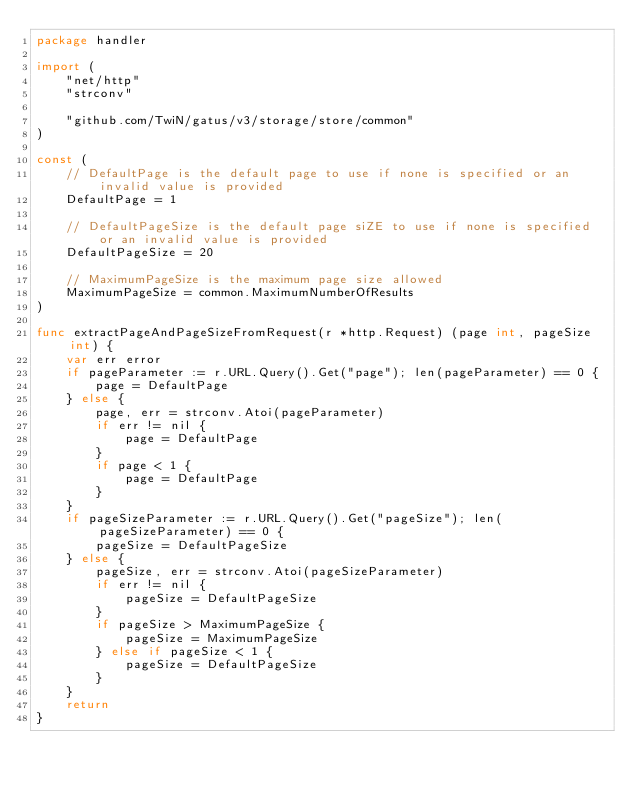<code> <loc_0><loc_0><loc_500><loc_500><_Go_>package handler

import (
	"net/http"
	"strconv"

	"github.com/TwiN/gatus/v3/storage/store/common"
)

const (
	// DefaultPage is the default page to use if none is specified or an invalid value is provided
	DefaultPage = 1

	// DefaultPageSize is the default page siZE to use if none is specified or an invalid value is provided
	DefaultPageSize = 20

	// MaximumPageSize is the maximum page size allowed
	MaximumPageSize = common.MaximumNumberOfResults
)

func extractPageAndPageSizeFromRequest(r *http.Request) (page int, pageSize int) {
	var err error
	if pageParameter := r.URL.Query().Get("page"); len(pageParameter) == 0 {
		page = DefaultPage
	} else {
		page, err = strconv.Atoi(pageParameter)
		if err != nil {
			page = DefaultPage
		}
		if page < 1 {
			page = DefaultPage
		}
	}
	if pageSizeParameter := r.URL.Query().Get("pageSize"); len(pageSizeParameter) == 0 {
		pageSize = DefaultPageSize
	} else {
		pageSize, err = strconv.Atoi(pageSizeParameter)
		if err != nil {
			pageSize = DefaultPageSize
		}
		if pageSize > MaximumPageSize {
			pageSize = MaximumPageSize
		} else if pageSize < 1 {
			pageSize = DefaultPageSize
		}
	}
	return
}
</code> 